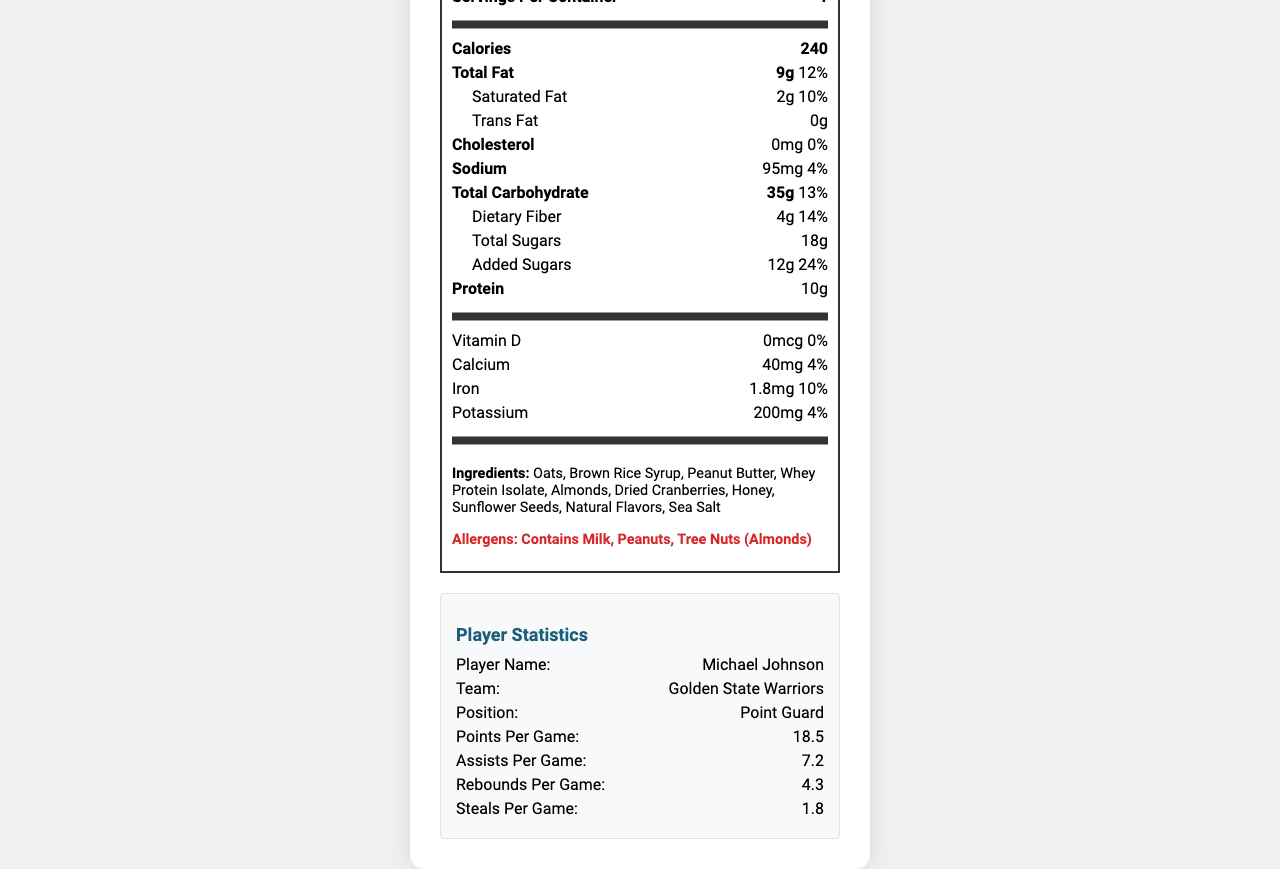describe the main content of the document The document aims to provide comprehensive nutritional information about the energy bar, customization choices, and ways to engage fans, alongside player statistics and sustainability initiatives.
Answer: The document contains a nutrition facts label for a customizable energy bar called "FanFuel Energy Bar." It includes detailed nutritional information, ingredients, allergen warnings, player statistics for a basketball player Michael Johnson, customization options for the energy bar, fan engagement features, sustainability information, and manufacturer details. what is the serving size of the FanFuel Energy Bar? The document explicitly states that the serving size is 1 bar (60g).
Answer: 1 bar (60g) how many calories are in one serving of the FanFuel Energy Bar? The calories per serving are shown prominently in the document.
Answer: 240 calories what is the total carbohydrate content and its daily value percentage? The total carbohydrate content is 35g, and the daily value percentage is 13%, as listed in the document.
Answer: 35g, 13% what are the top three ingredients in the FanFuel Energy Bar? The ingredients list is provided in the document, and the top three listed are Oats, Brown Rice Syrup, and Peanut Butter.
Answer: Oats, Brown Rice Syrup, Peanut Butter how much protein does the FanFuel Energy Bar contain? The document lists the protein content as 10g.
Answer: 10g how can you customize the FanFuel Energy Bar to increase its fiber content? The Endurance Mix option increases fiber by 2g and adds chia seeds and coconut, as mentioned in the customization options.
Answer: Add “Endurance Mix” which allergen is NOT mentioned in the FanFuel Energy Bar ingredients? The listed allergens are milk, peanuts, and tree nuts (almonds). Soy is not mentioned.
Answer: Soy what team's player statistics are included in the document? Michael Johnson’s player statistics for the Golden State Warriors are included in the document.
Answer: Golden State Warriors what position does Michael Johnson play? Michael Johnson plays the position of Point Guard, as stated in the player statistics section.
Answer: Point Guard what features are included for fan engagement? These three fan engagement features are explicitly listed in the document.
Answer: QR code linking to player's career highlights, Collectible wrapper designs featuring team roster, Chance to win VIP game-day experiences with every purchase what is the recommended daily value percentage of vitamin D in the FanFuel Energy Bar? The document lists the vitamin D content as 0mcg, which corresponds to 0% of the recommended daily value.
Answer: 0% how many grams of saturated fat does the bar contain, and what is the daily value percentage? The document clearly states that the bar contains 2g of saturated fat, which is 10% of the daily value.
Answer: 2g, 10% which customization option adds 5g of protein? The “Protein Boost” customization option is described as adding 5g of protein.
Answer: Protein Boost what is the serving size option for the FanFuel Energy Bar? A. 30g B. 50g C. 60g D. 70g The serving size of the FanFuel Energy Bar is stated as 1 bar (60g).
Answer: C which is the correct daily value % for iron in the FanFuel Energy Bar? A. 5% B. 10% C. 15% D. 20% The document states the iron content daily value percentage as 10%.
Answer: B does the FanFuel Energy Bar contain any trans fat? The document lists the trans fat content as 0g, meaning it does not contain any trans fat.
Answer: No is the wrapper of the FanFuel Energy Bar sustainable? The sustainability info mentioned in the document states that the wrapper is made from 100% recycled materials.
Answer: Yes what is the main ingredient in terms of allergens? Peanuts are one of the listed allergens and a main ingredient in the bar.
Answer: Peanuts how does the document bridge nutrition and fan engagement for sports enthusiasts? The document provides nutritional information while also including player statistics and interactive features to engage sports fans.
Answer: By combining detailed nutrition facts with player statistics and fan engagement features like career highlights, collectible designs, and chances to win game-day experiences. can we determine the manufacturer address's postal code? The manufacturer's address is listed in the document as Oakland, CA 94621.
Answer: Yes, it's 94621 which ingredient is listed last among the ingredients? Among the ingredients listed, Sea Salt appears last.
Answer: Sea Salt how many customization options are available for the FanFuel Energy Bar? The document lists three customization options: Protein Boost, Endurance Mix, and Antioxidant Blend.
Answer: Three what is the sodium content as per the recommended daily value? The document states the sodium content as 95mg, which corresponds to 4% of the recommended daily value.
Answer: 95mg, 4% is there enough information to know the exact price of the FanFuel Energy Bar? The document does not provide any pricing information.
Answer: No how can fans interact with the player statistics presented in the document? The fan engagement features include a QR code that links to Michael Johnson's career highlights.
Answer: They can scan a QR code linking to the player's career highlights. is the FanFuel Energy Bar suitable for people allergic to tree nuts? The document lists almonds (a tree nut) as an ingredient, making it unsuitable for people allergic to tree nuts.
Answer: No 